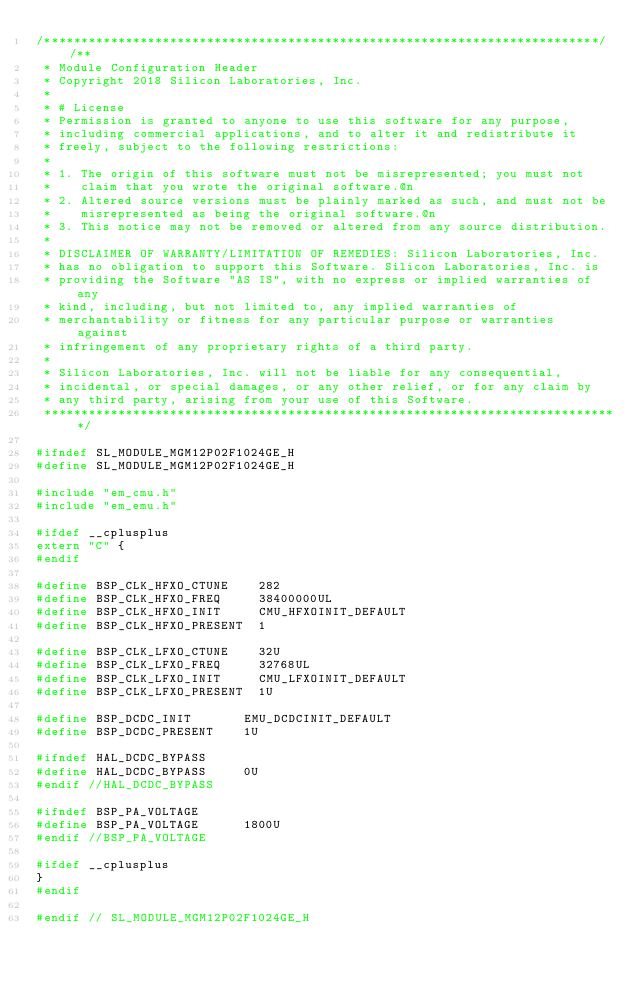Convert code to text. <code><loc_0><loc_0><loc_500><loc_500><_C_>/***************************************************************************//**
 * Module Configuration Header
 * Copyright 2018 Silicon Laboratories, Inc.
 *
 * # License
 * Permission is granted to anyone to use this software for any purpose,
 * including commercial applications, and to alter it and redistribute it
 * freely, subject to the following restrictions:
 *
 * 1. The origin of this software must not be misrepresented; you must not
 *    claim that you wrote the original software.@n
 * 2. Altered source versions must be plainly marked as such, and must not be
 *    misrepresented as being the original software.@n
 * 3. This notice may not be removed or altered from any source distribution.
 *
 * DISCLAIMER OF WARRANTY/LIMITATION OF REMEDIES: Silicon Laboratories, Inc.
 * has no obligation to support this Software. Silicon Laboratories, Inc. is
 * providing the Software "AS IS", with no express or implied warranties of any
 * kind, including, but not limited to, any implied warranties of
 * merchantability or fitness for any particular purpose or warranties against
 * infringement of any proprietary rights of a third party.
 *
 * Silicon Laboratories, Inc. will not be liable for any consequential,
 * incidental, or special damages, or any other relief, or for any claim by
 * any third party, arising from your use of this Software.
 ******************************************************************************/
 
#ifndef SL_MODULE_MGM12P02F1024GE_H
#define SL_MODULE_MGM12P02F1024GE_H

#include "em_cmu.h"
#include "em_emu.h"

#ifdef __cplusplus
extern "C" {
#endif

#define BSP_CLK_HFXO_CTUNE 		282
#define BSP_CLK_HFXO_FREQ 		38400000UL
#define BSP_CLK_HFXO_INIT 		CMU_HFXOINIT_DEFAULT
#define BSP_CLK_HFXO_PRESENT 	1

#define BSP_CLK_LFXO_CTUNE 		32U
#define BSP_CLK_LFXO_FREQ 		32768UL
#define BSP_CLK_LFXO_INIT 		CMU_LFXOINIT_DEFAULT
#define BSP_CLK_LFXO_PRESENT 	1U

#define BSP_DCDC_INIT 			EMU_DCDCINIT_DEFAULT
#define BSP_DCDC_PRESENT 		1U

#ifndef HAL_DCDC_BYPASS
#define HAL_DCDC_BYPASS 		0U
#endif //HAL_DCDC_BYPASS

#ifndef BSP_PA_VOLTAGE
#define BSP_PA_VOLTAGE 			1800U
#endif //BSP_PA_VOLTAGE

#ifdef __cplusplus
}
#endif

#endif // SL_MODULE_MGM12P02F1024GE_H
</code> 